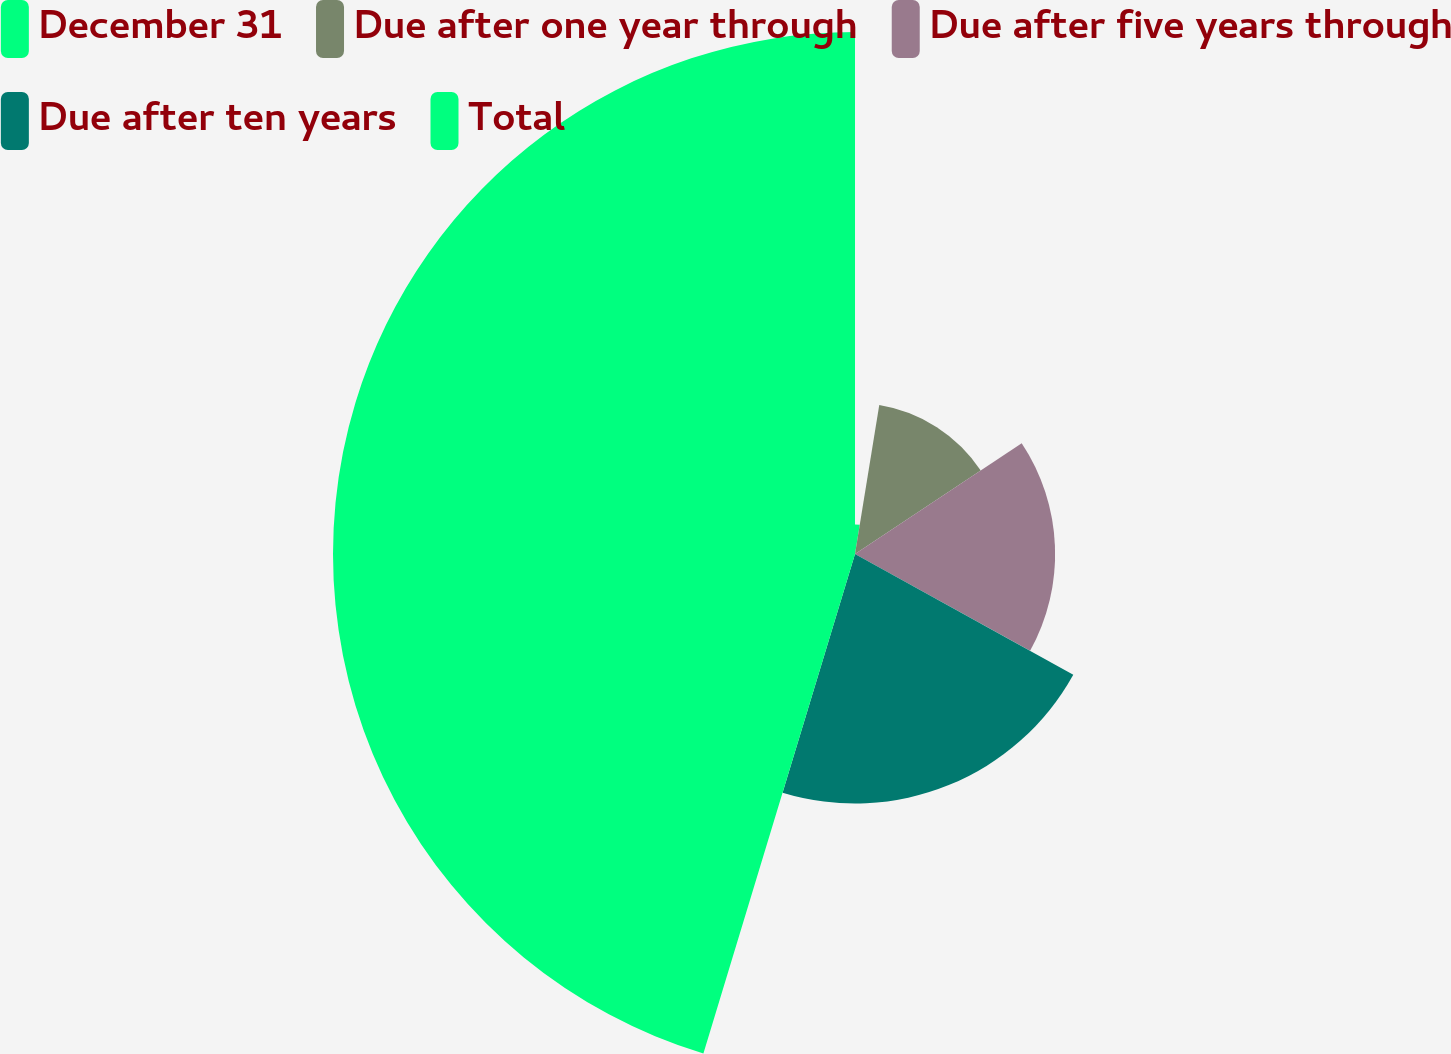<chart> <loc_0><loc_0><loc_500><loc_500><pie_chart><fcel>December 31<fcel>Due after one year through<fcel>Due after five years through<fcel>Due after ten years<fcel>Total<nl><fcel>2.57%<fcel>13.1%<fcel>17.37%<fcel>21.65%<fcel>45.31%<nl></chart> 